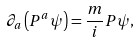<formula> <loc_0><loc_0><loc_500><loc_500>\partial _ { a } \left ( P ^ { a } \psi \right ) = \frac { m } { i } P \psi ,</formula> 